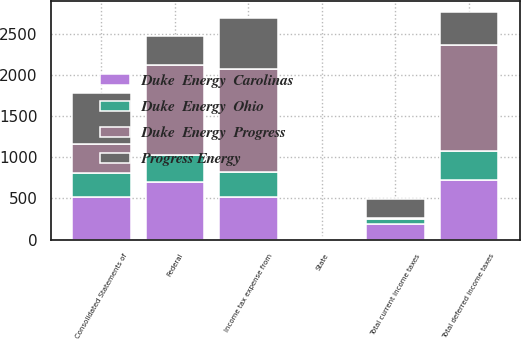Convert chart to OTSL. <chart><loc_0><loc_0><loc_500><loc_500><stacked_bar_chart><ecel><fcel>State<fcel>Total current income taxes<fcel>Federal<fcel>Total deferred income taxes<fcel>Income tax expense from<fcel>Consolidated Statements of<nl><fcel>Duke  Energy  Progress<fcel>12<fcel>8<fcel>1097<fcel>1278<fcel>1256<fcel>345<nl><fcel>Progress Energy<fcel>14<fcel>230<fcel>345<fcel>402<fcel>627<fcel>627<nl><fcel>Duke  Energy  Carolinas<fcel>1<fcel>192<fcel>694<fcel>721<fcel>522<fcel>521<nl><fcel>Duke  Energy  Ohio<fcel>4<fcel>60<fcel>334<fcel>361<fcel>294<fcel>294<nl></chart> 